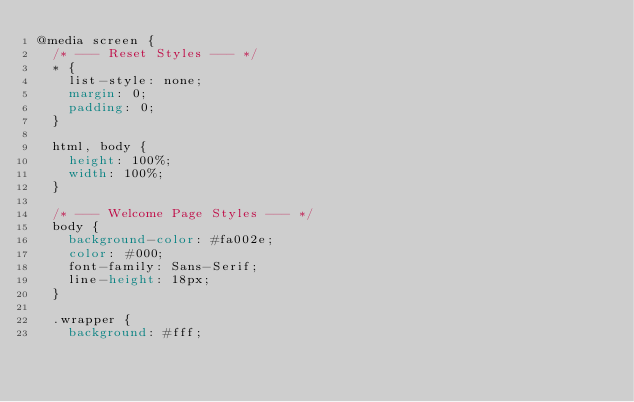<code> <loc_0><loc_0><loc_500><loc_500><_CSS_>@media screen {
  /* --- Reset Styles --- */
  * {
    list-style: none;
    margin: 0;
    padding: 0;
  }

  html, body {
    height: 100%;
    width: 100%;
  }

  /* --- Welcome Page Styles --- */
  body {
    background-color: #fa002e;
    color: #000;
    font-family: Sans-Serif;
    line-height: 18px;
  }

  .wrapper {
    background: #fff;</code> 